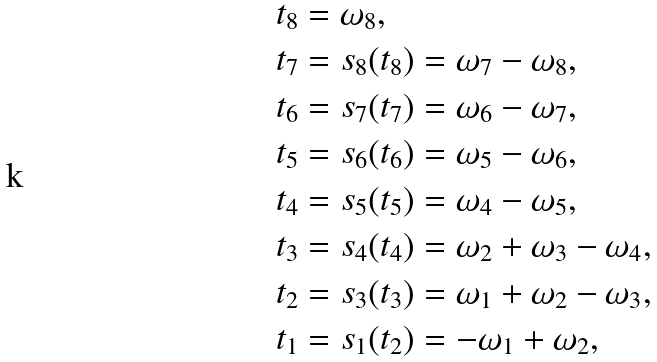Convert formula to latex. <formula><loc_0><loc_0><loc_500><loc_500>t _ { 8 } & = \omega _ { 8 } , \\ t _ { 7 } & = s _ { 8 } ( t _ { 8 } ) = \omega _ { 7 } - \omega _ { 8 } , \\ t _ { 6 } & = s _ { 7 } ( t _ { 7 } ) = \omega _ { 6 } - \omega _ { 7 } , \\ t _ { 5 } & = s _ { 6 } ( t _ { 6 } ) = \omega _ { 5 } - \omega _ { 6 } , \\ t _ { 4 } & = s _ { 5 } ( t _ { 5 } ) = \omega _ { 4 } - \omega _ { 5 } , \\ t _ { 3 } & = s _ { 4 } ( t _ { 4 } ) = \omega _ { 2 } + \omega _ { 3 } - \omega _ { 4 } , \\ t _ { 2 } & = s _ { 3 } ( t _ { 3 } ) = \omega _ { 1 } + \omega _ { 2 } - \omega _ { 3 } , \\ t _ { 1 } & = s _ { 1 } ( t _ { 2 } ) = - \omega _ { 1 } + \omega _ { 2 } ,</formula> 